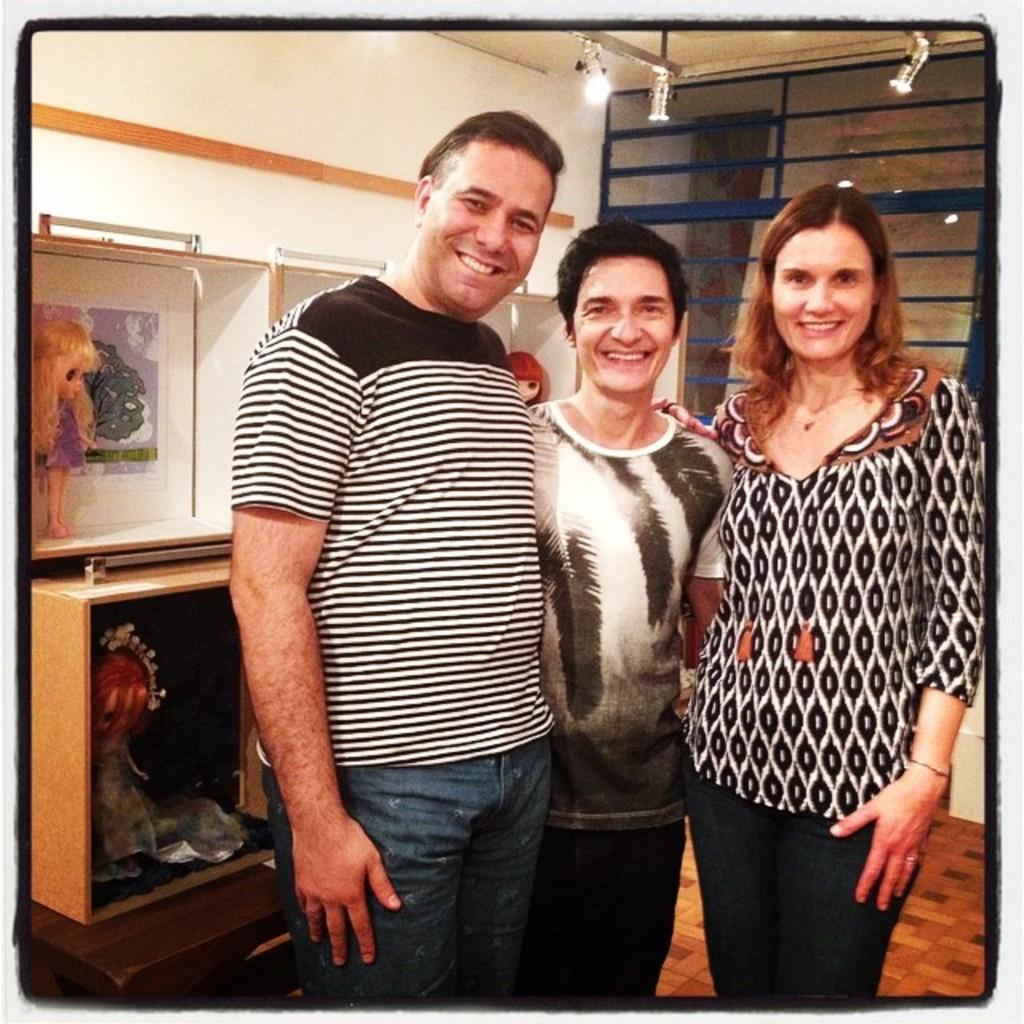Could you give a brief overview of what you see in this image? In this image in the front there are persons standing and smiling. In the background there is wall and on the wall there are frames. In front of the wall, there is a table and on the table there is a shelf and in the shelf there are dolls and on the top there are lights and there is a door. 